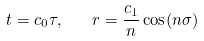Convert formula to latex. <formula><loc_0><loc_0><loc_500><loc_500>t = c _ { 0 } \tau , \quad r = \frac { c _ { 1 } } { n } \cos ( n \sigma )</formula> 